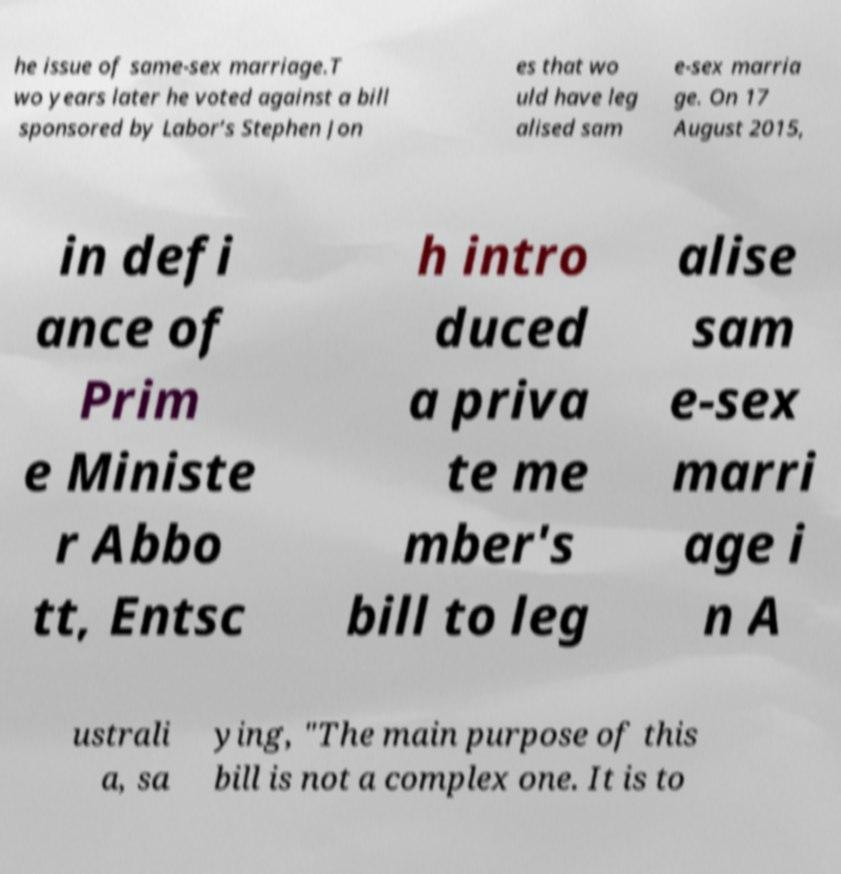What messages or text are displayed in this image? I need them in a readable, typed format. he issue of same-sex marriage.T wo years later he voted against a bill sponsored by Labor’s Stephen Jon es that wo uld have leg alised sam e-sex marria ge. On 17 August 2015, in defi ance of Prim e Ministe r Abbo tt, Entsc h intro duced a priva te me mber's bill to leg alise sam e-sex marri age i n A ustrali a, sa ying, "The main purpose of this bill is not a complex one. It is to 